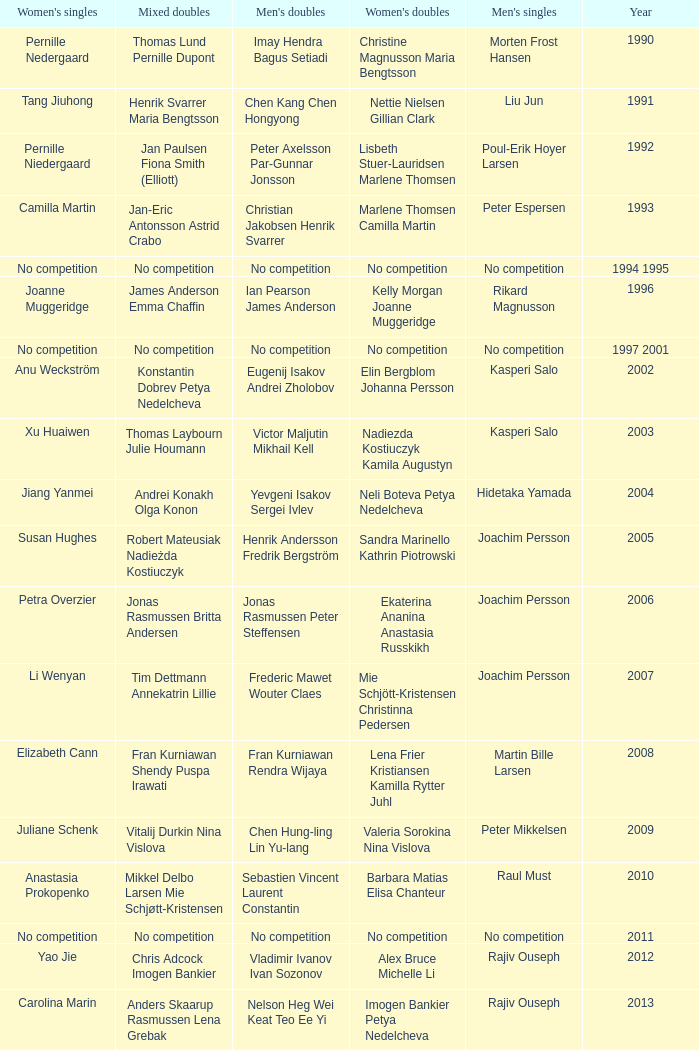What year did Carolina Marin win the Women's singles? 2013.0. 